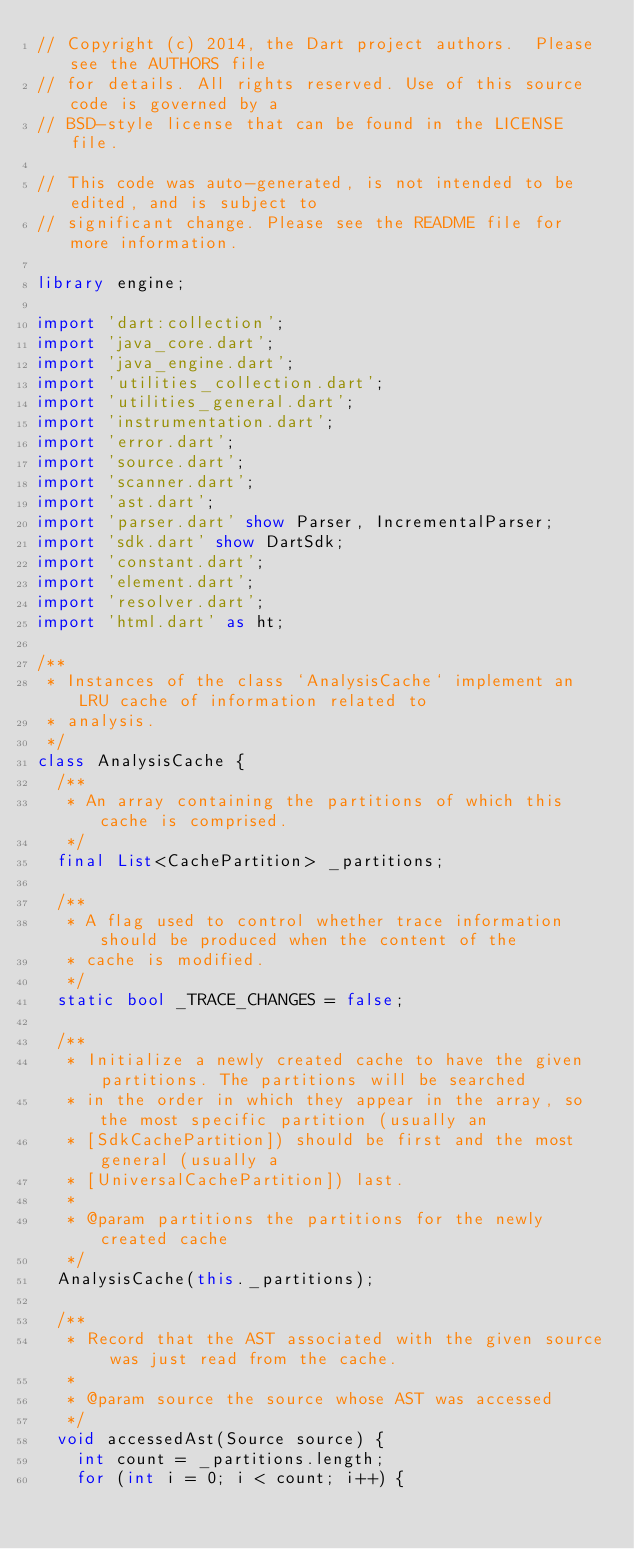<code> <loc_0><loc_0><loc_500><loc_500><_Dart_>// Copyright (c) 2014, the Dart project authors.  Please see the AUTHORS file
// for details. All rights reserved. Use of this source code is governed by a
// BSD-style license that can be found in the LICENSE file.

// This code was auto-generated, is not intended to be edited, and is subject to
// significant change. Please see the README file for more information.

library engine;

import 'dart:collection';
import 'java_core.dart';
import 'java_engine.dart';
import 'utilities_collection.dart';
import 'utilities_general.dart';
import 'instrumentation.dart';
import 'error.dart';
import 'source.dart';
import 'scanner.dart';
import 'ast.dart';
import 'parser.dart' show Parser, IncrementalParser;
import 'sdk.dart' show DartSdk;
import 'constant.dart';
import 'element.dart';
import 'resolver.dart';
import 'html.dart' as ht;

/**
 * Instances of the class `AnalysisCache` implement an LRU cache of information related to
 * analysis.
 */
class AnalysisCache {
  /**
   * An array containing the partitions of which this cache is comprised.
   */
  final List<CachePartition> _partitions;

  /**
   * A flag used to control whether trace information should be produced when the content of the
   * cache is modified.
   */
  static bool _TRACE_CHANGES = false;

  /**
   * Initialize a newly created cache to have the given partitions. The partitions will be searched
   * in the order in which they appear in the array, so the most specific partition (usually an
   * [SdkCachePartition]) should be first and the most general (usually a
   * [UniversalCachePartition]) last.
   *
   * @param partitions the partitions for the newly created cache
   */
  AnalysisCache(this._partitions);

  /**
   * Record that the AST associated with the given source was just read from the cache.
   *
   * @param source the source whose AST was accessed
   */
  void accessedAst(Source source) {
    int count = _partitions.length;
    for (int i = 0; i < count; i++) {</code> 